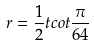<formula> <loc_0><loc_0><loc_500><loc_500>r = \frac { 1 } { 2 } t c o t \frac { \pi } { 6 4 }</formula> 